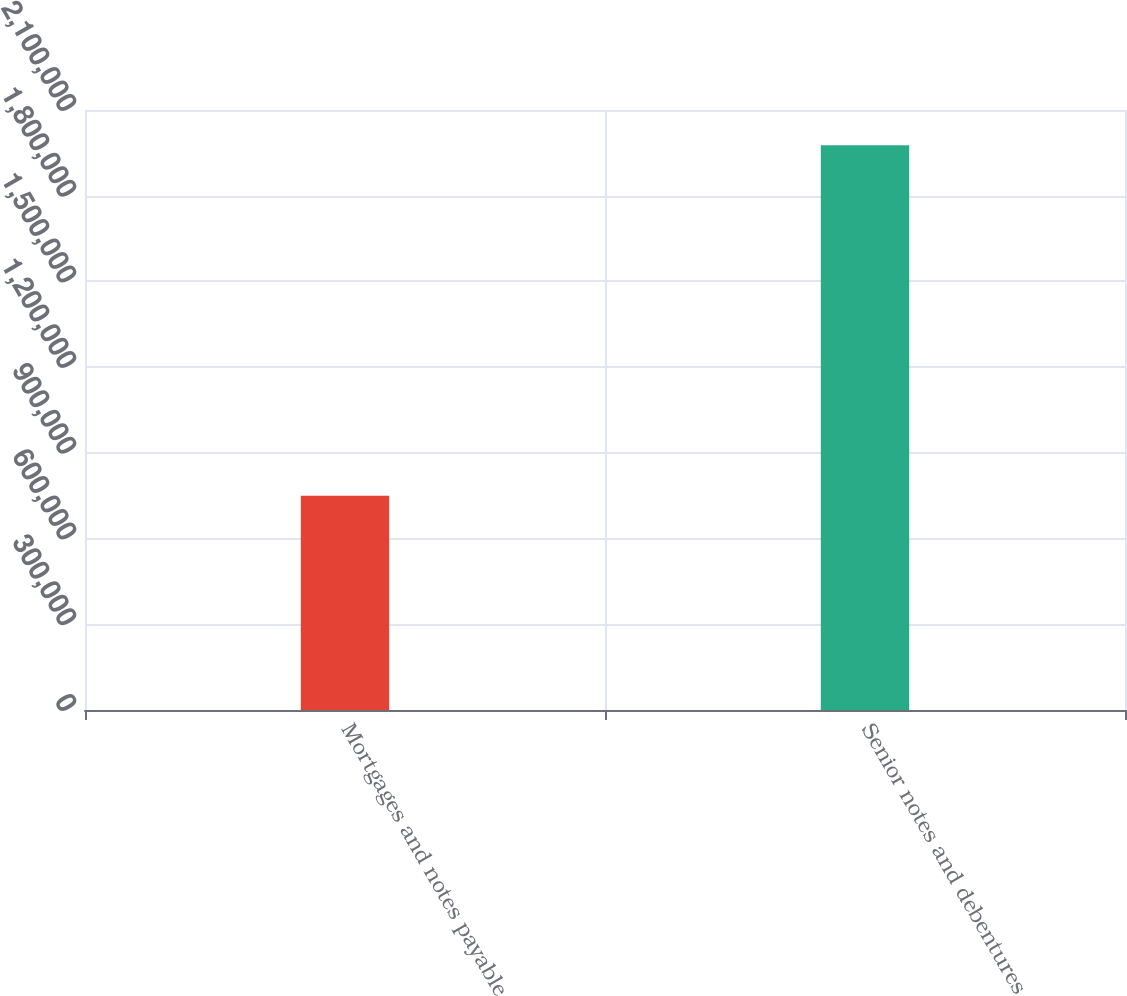Convert chart. <chart><loc_0><loc_0><loc_500><loc_500><bar_chart><fcel>Mortgages and notes payable<fcel>Senior notes and debentures<nl><fcel>750268<fcel>1.97659e+06<nl></chart> 